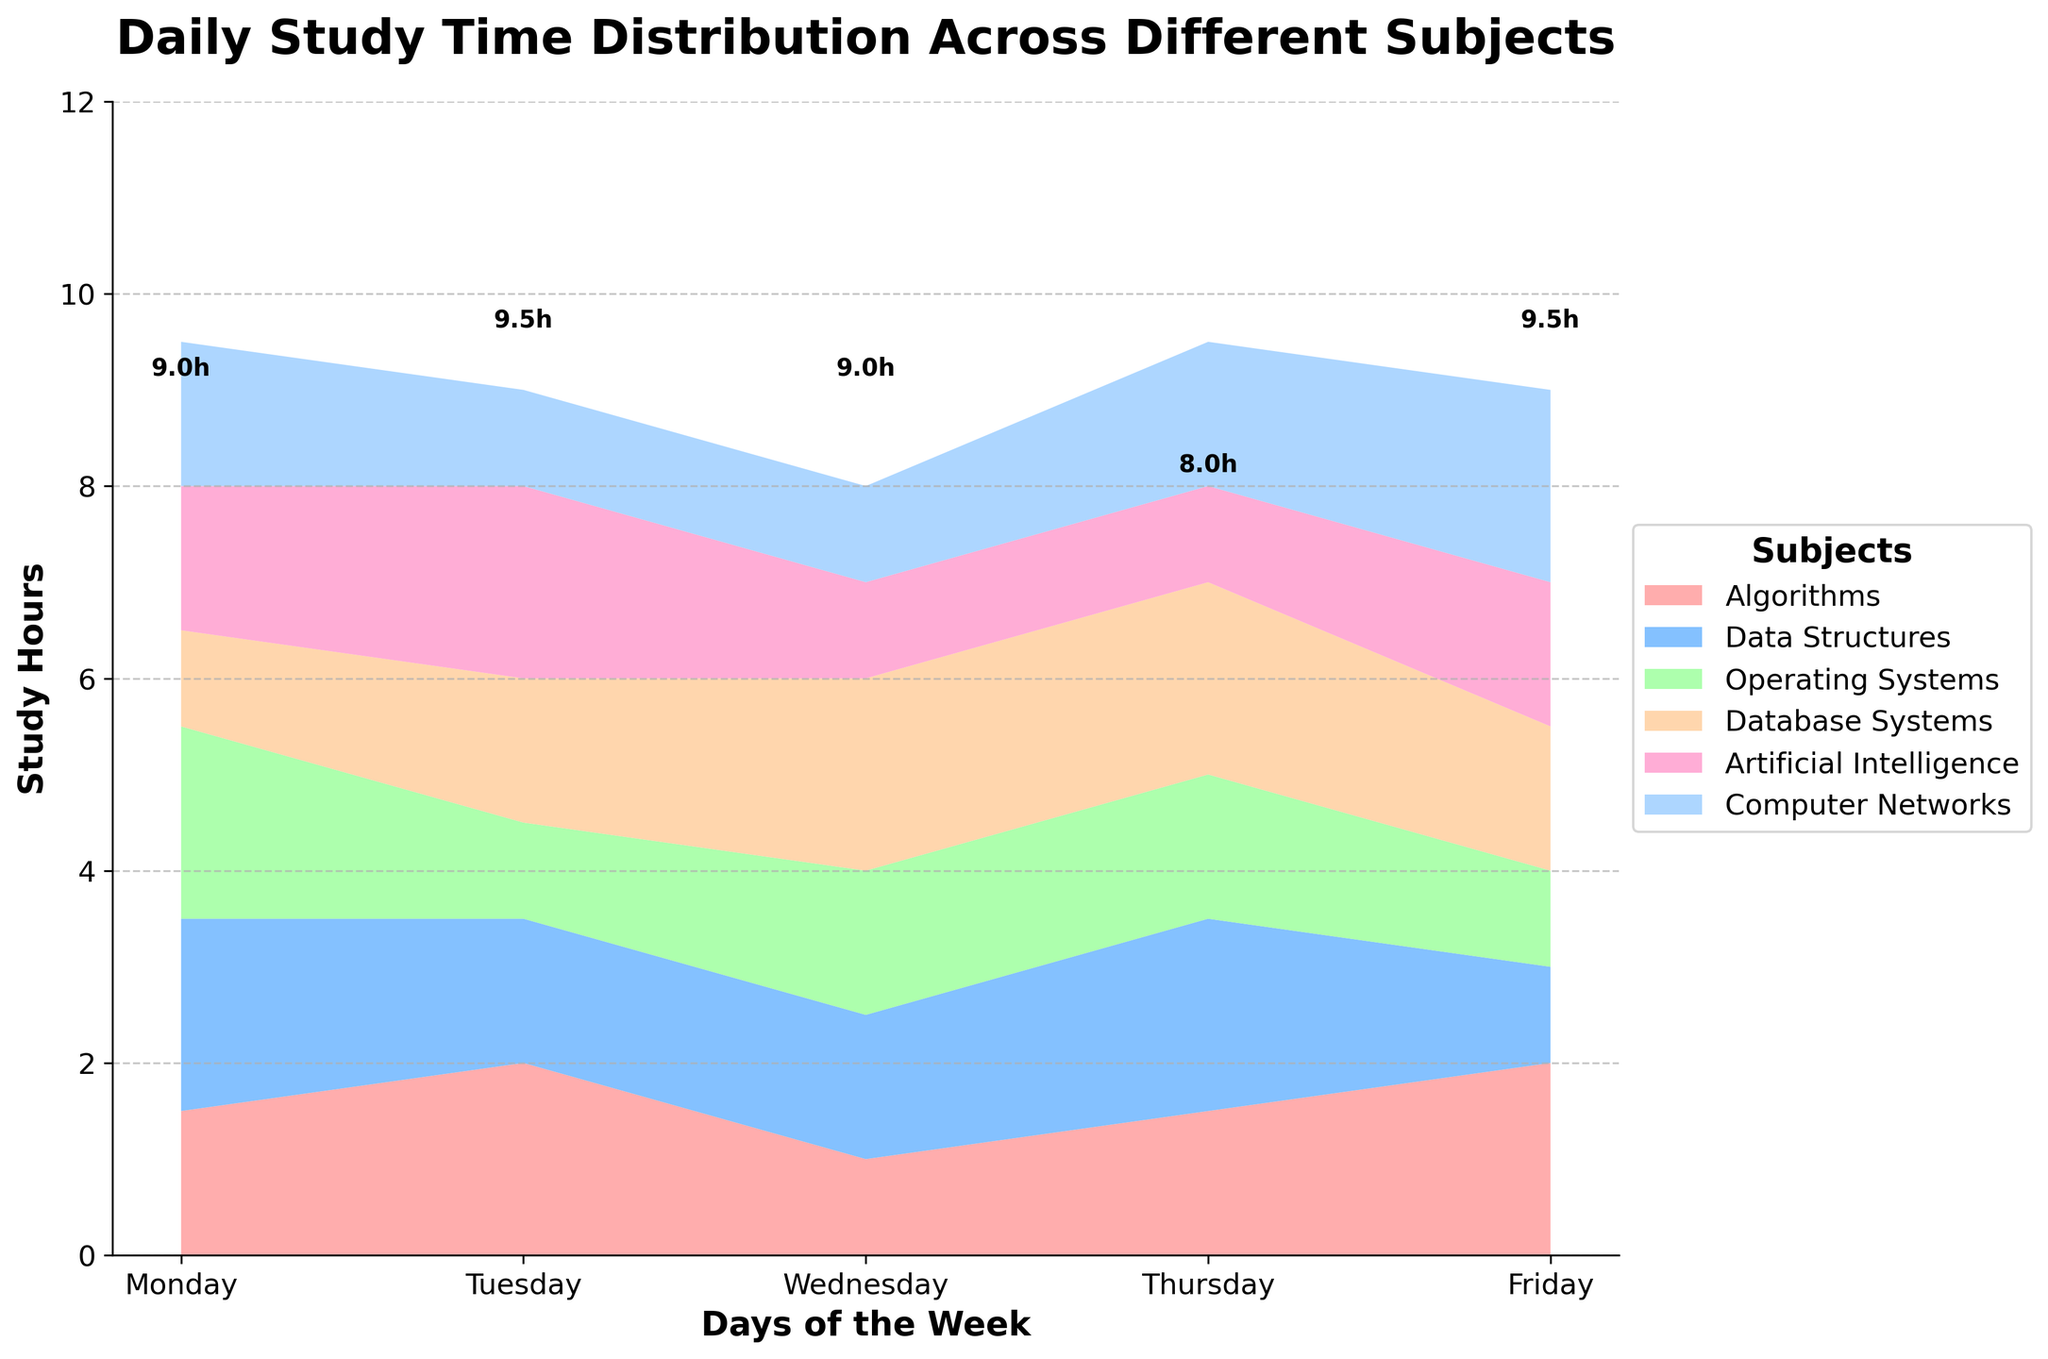Which subject has the highest total study hours on Monday? To find the answer, look at the height of each subject's area plotted for Monday. Algorithms and Database Systems each have 2 hours, which is the highest for Monday.
Answer: Algorithms and Database Systems Which day has the highest total study hours across all subjects? Add the height of all the subject areas stacked on each day. Wednesday has the highest total study hours at 9.0 hours.
Answer: Wednesday How many study hours are allocated to Data Structures on Thursday? Locate the day Thursday and check the height of the Data Structures area. The height is given as 2 hours.
Answer: 2 Compare the study hours of Operating Systems and Artificial Intelligence on Tuesday. Which one is higher? trace the Tuesday column and compare the heights of the Operating Systems and Artificial Intelligence areas. AI has 2 hours, while Operating Systems has 1.5 hours. AI has more study hours.
Answer: Artificial Intelligence Which subject shows the most variation in study hours across the week? Look at the plots by focusing on the range (max-min) of each subject's area. The Algorithms subject shows significant variation, ranging from 1 to 2 hours.
Answer: Algorithms What is the total study time for Artificial Intelligence across the week? Sum the hours from Monday to Friday: 1.5 + 2 + 1 + 1.5 + 2 = 8
Answer: 8 On which day do female computer science students spend the least amount of time studying? Compare the total areas stacked for Monday through Friday. Thursday has the lowest total study time at 8 hours.
Answer: Thursday Which subject has the least study hours across the week? Sum the study hours for each subject and determine which is the lowest. Computer Networks has the least, with 1 + 1.5 + 1 + 1.5 + 2 = 7.
Answer: Computer Networks Is there any subject with a consistent study time throughout the week? Look for a subject whose area height doesn't fluctuate from Monday to Friday. No subject meets this criterion as they all have varying study hours.
Answer: No How does the total study time for Algorithms compare to Data Structures on Friday? Trace the Friday areas for both subjects. Algorithms is 1.5 hours, and Data Structures is 1 hour. Algorithms has more time.
Answer: Algorithms 